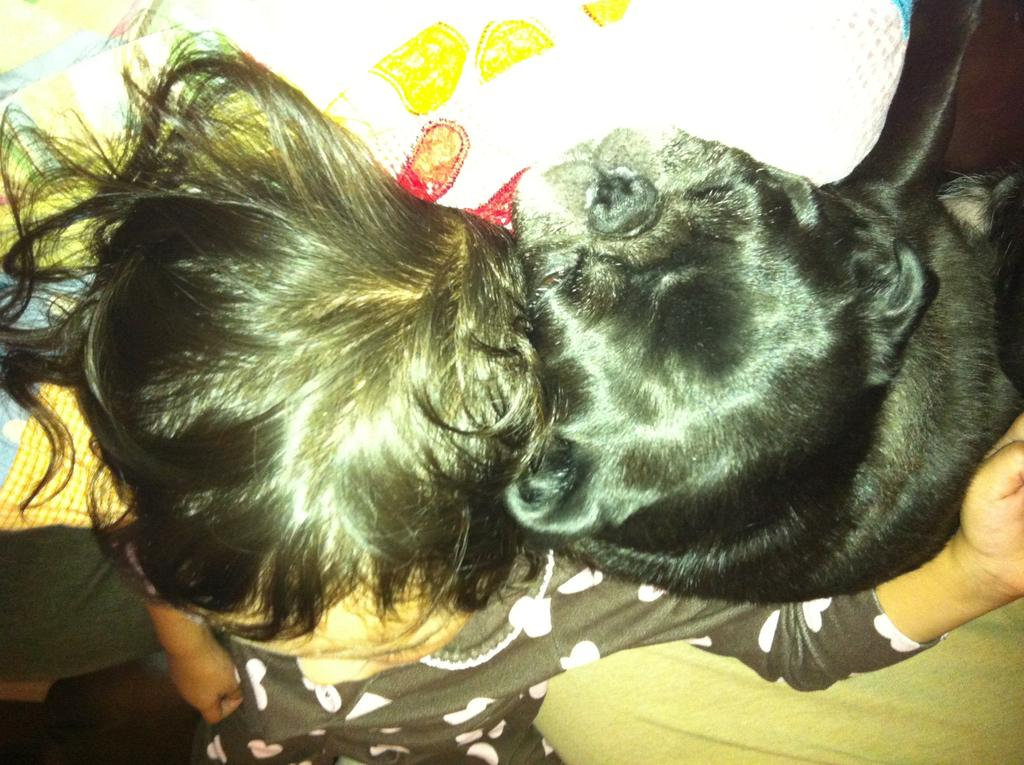What is the main subject of the image? There is a child in the image. What is the child doing in the image? The child is sleeping on the bed. Are there any other living beings in the image? Yes, there is a dog in the image. What is the dog doing in the image? The dog is sleeping on the bed. What type of impulse can be seen traveling through the glass in the image? There is no glass or impulse present in the image. What is the child's dad doing in the image? There is no dad present in the image. 